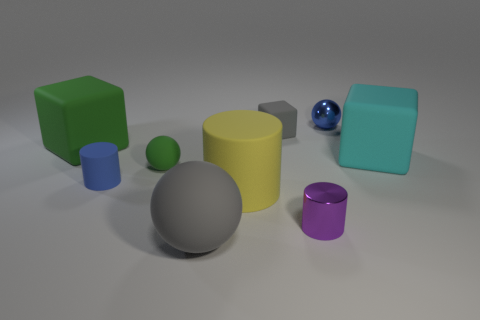What size is the blue rubber thing that is the same shape as the tiny purple metallic thing?
Give a very brief answer. Small. Is the number of big cylinders in front of the small rubber cube greater than the number of small green rubber balls that are in front of the blue rubber object?
Your answer should be compact. Yes. The object that is in front of the large yellow matte cylinder and right of the yellow cylinder is made of what material?
Ensure brevity in your answer.  Metal. There is another tiny rubber object that is the same shape as the purple object; what is its color?
Ensure brevity in your answer.  Blue. How big is the yellow thing?
Offer a very short reply. Large. What is the color of the small ball to the right of the green rubber sphere that is to the left of the big yellow thing?
Your response must be concise. Blue. What number of objects are both to the left of the blue matte cylinder and in front of the big yellow matte cylinder?
Your response must be concise. 0. Is the number of small gray blocks greater than the number of green objects?
Your answer should be compact. No. What is the small purple cylinder made of?
Provide a short and direct response. Metal. There is a big matte thing on the right side of the purple cylinder; what number of metal spheres are behind it?
Offer a very short reply. 1. 